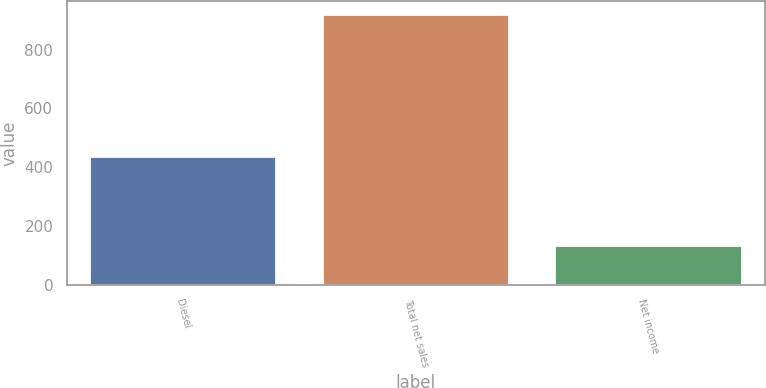<chart> <loc_0><loc_0><loc_500><loc_500><bar_chart><fcel>Diesel<fcel>Total net sales<fcel>Net income<nl><fcel>434<fcel>919<fcel>130<nl></chart> 